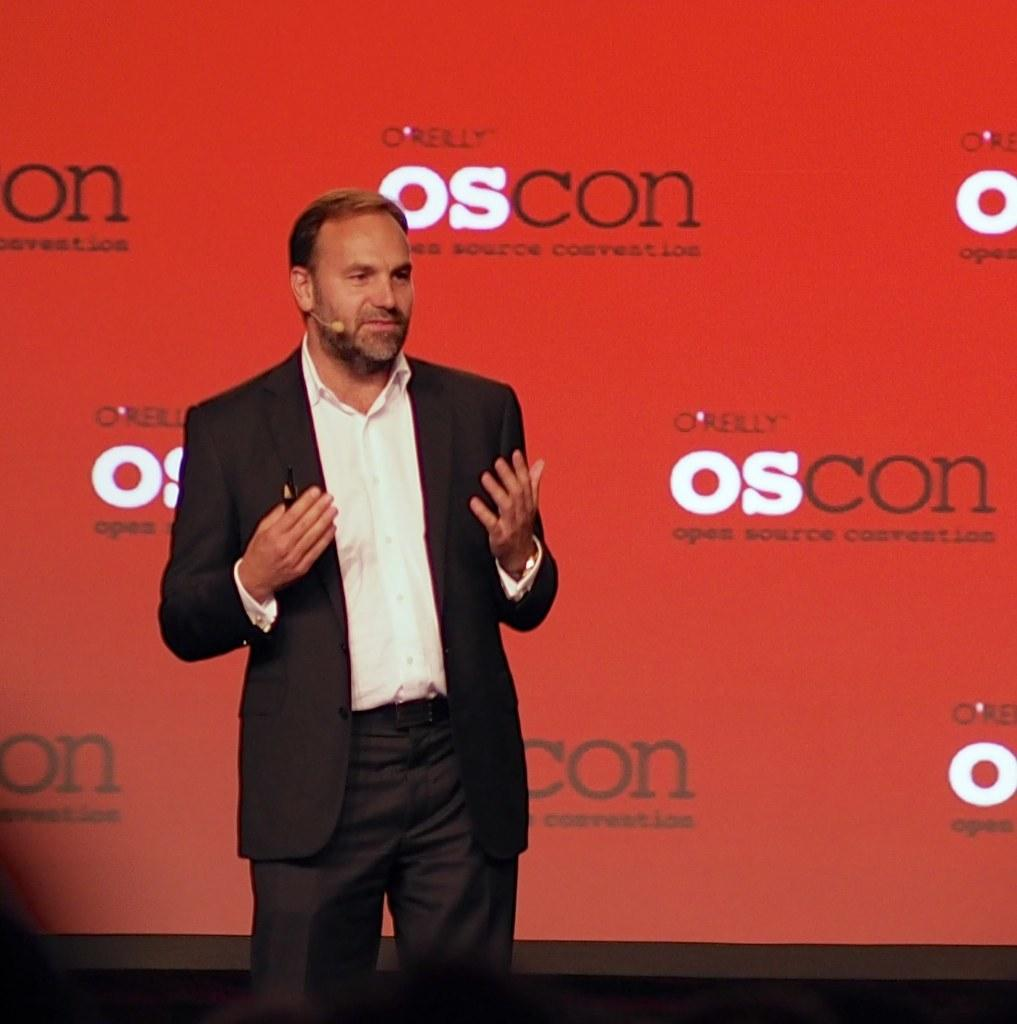What is the main subject of the image? There is a person standing in the center of the image. What is the person holding in the image? The person is holding an object. What can be seen in the background of the image? There is a banner in the background of the image. What is the son's name in the image? There is no mention of a son or any names in the image. What observation can be made about the person's facial expression in the image? The provided facts do not mention the person's facial expression, so it cannot be determined from the image. 